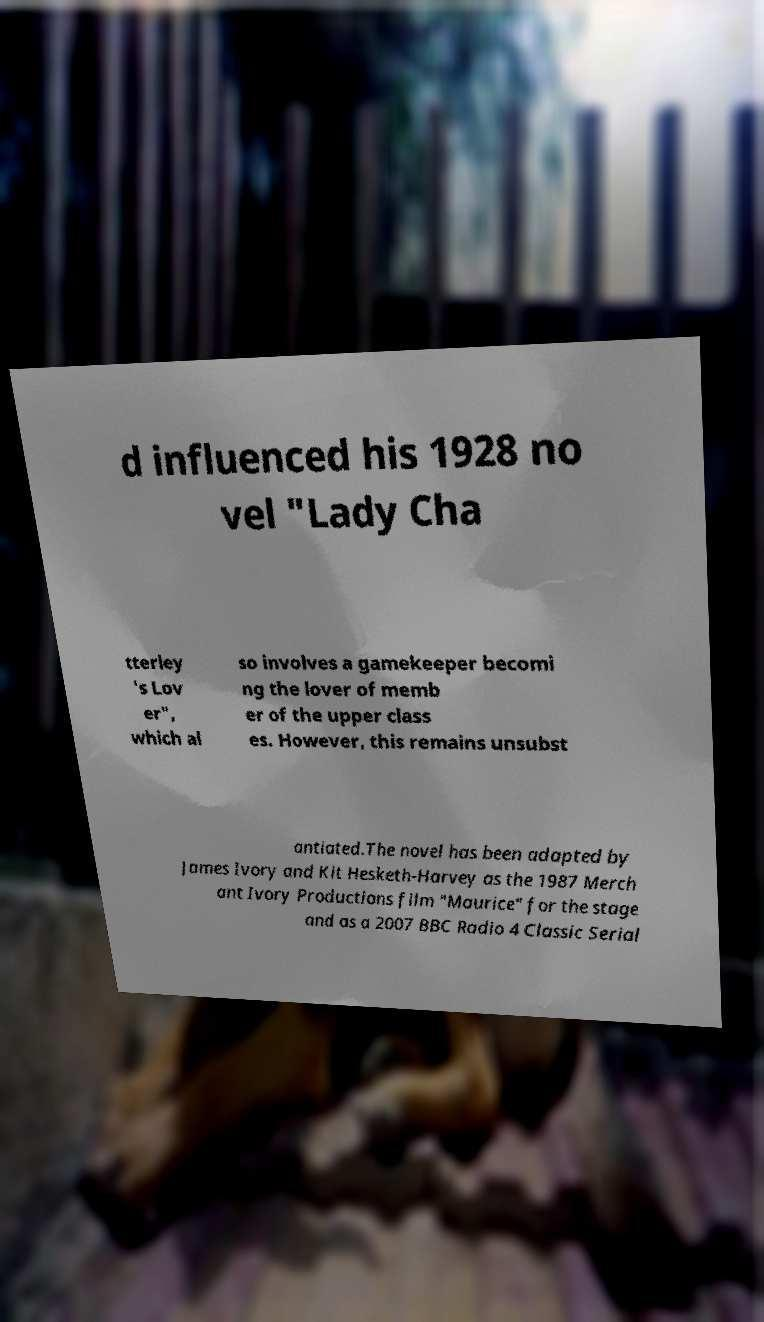For documentation purposes, I need the text within this image transcribed. Could you provide that? d influenced his 1928 no vel "Lady Cha tterley 's Lov er", which al so involves a gamekeeper becomi ng the lover of memb er of the upper class es. However, this remains unsubst antiated.The novel has been adapted by James Ivory and Kit Hesketh-Harvey as the 1987 Merch ant Ivory Productions film "Maurice" for the stage and as a 2007 BBC Radio 4 Classic Serial 